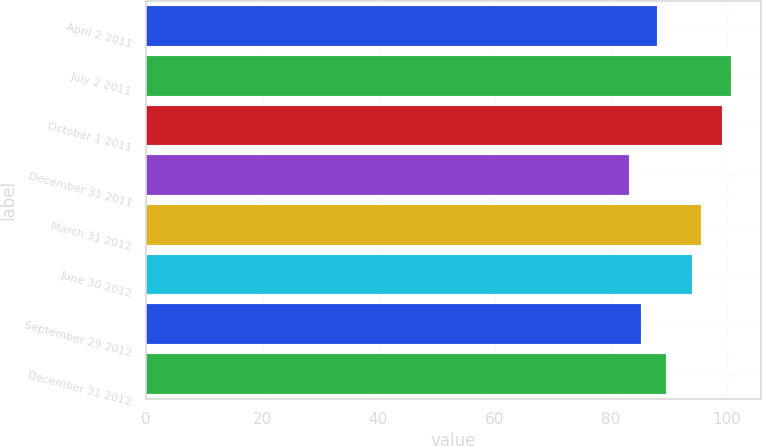<chart> <loc_0><loc_0><loc_500><loc_500><bar_chart><fcel>April 2 2011<fcel>July 2 2011<fcel>October 1 2011<fcel>December 31 2011<fcel>March 31 2012<fcel>June 30 2012<fcel>September 29 2012<fcel>December 31 2012<nl><fcel>87.93<fcel>100.8<fcel>99.16<fcel>83.14<fcel>95.63<fcel>93.99<fcel>85.24<fcel>89.57<nl></chart> 